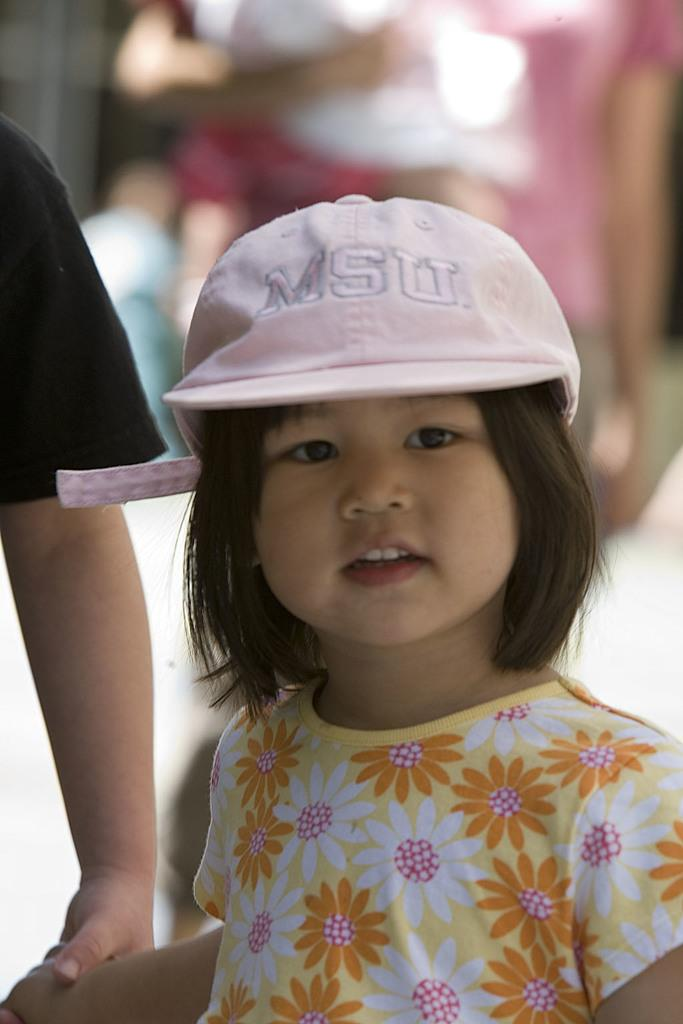Who is the main subject in the image? There is a girl in the image. What is the girl wearing on her head? The girl is wearing a cap. Can you describe the person accompanying the girl? The person is wearing a black T-shirt and is holding the girl's hand. What is happening in the background of the image? There are people walking in the background of the image. What type of plantation can be seen in the image? There is no plantation present in the image. How many boys are visible in the image? The image only features a girl and a person, so there are no boys visible. 